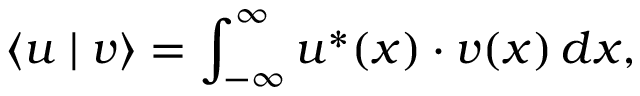<formula> <loc_0><loc_0><loc_500><loc_500>\langle u | v \rangle = \int _ { - \infty } ^ { \infty } u ^ { * } ( x ) \cdot v ( x ) \, d x ,</formula> 